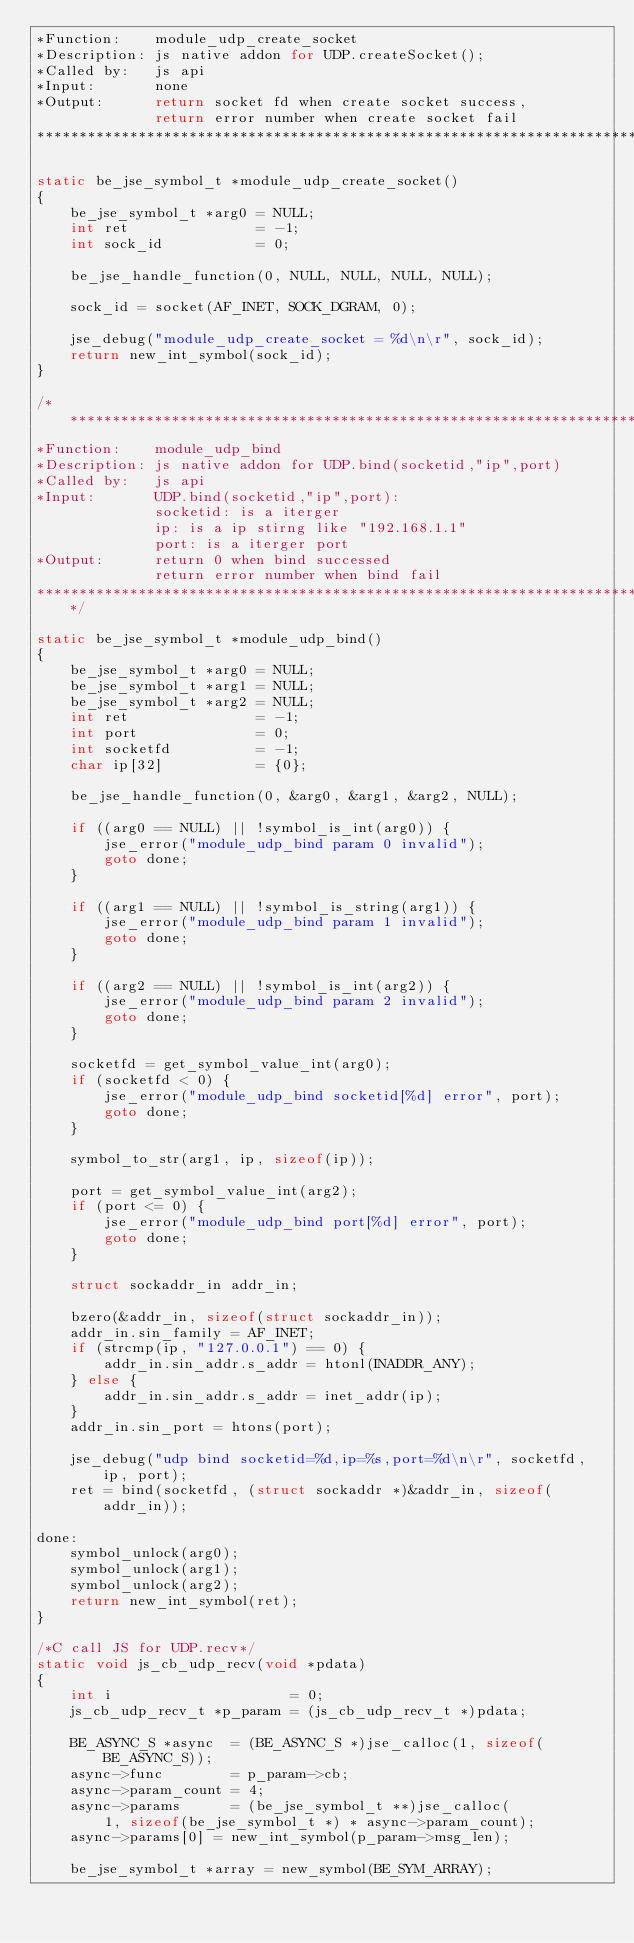Convert code to text. <code><loc_0><loc_0><loc_500><loc_500><_C_>*Function:    module_udp_create_socket
*Description: js native addon for UDP.createSocket();
*Called by:   js api
*Input:       none
*Output:      return socket fd when create socket success,
              return error number when create socket fail
**************************************************************************************/

static be_jse_symbol_t *module_udp_create_socket()
{
    be_jse_symbol_t *arg0 = NULL;
    int ret               = -1;
    int sock_id           = 0;

    be_jse_handle_function(0, NULL, NULL, NULL, NULL);

    sock_id = socket(AF_INET, SOCK_DGRAM, 0);

    jse_debug("module_udp_create_socket = %d\n\r", sock_id);
    return new_int_symbol(sock_id);
}

/*************************************************************************************
*Function:    module_udp_bind
*Description: js native addon for UDP.bind(socketid,"ip",port)
*Called by:   js api
*Input:       UDP.bind(socketid,"ip",port):
              socketid: is a iterger
              ip: is a ip stirng like "192.168.1.1"
              port: is a iterger port
*Output:      return 0 when bind successed
              return error number when bind fail
**************************************************************************************/

static be_jse_symbol_t *module_udp_bind()
{
    be_jse_symbol_t *arg0 = NULL;
    be_jse_symbol_t *arg1 = NULL;
    be_jse_symbol_t *arg2 = NULL;
    int ret               = -1;
    int port              = 0;
    int socketfd          = -1;
    char ip[32]           = {0};

    be_jse_handle_function(0, &arg0, &arg1, &arg2, NULL);

    if ((arg0 == NULL) || !symbol_is_int(arg0)) {
        jse_error("module_udp_bind param 0 invalid");
        goto done;
    }

    if ((arg1 == NULL) || !symbol_is_string(arg1)) {
        jse_error("module_udp_bind param 1 invalid");
        goto done;
    }

    if ((arg2 == NULL) || !symbol_is_int(arg2)) {
        jse_error("module_udp_bind param 2 invalid");
        goto done;
    }

    socketfd = get_symbol_value_int(arg0);
    if (socketfd < 0) {
        jse_error("module_udp_bind socketid[%d] error", port);
        goto done;
    }

    symbol_to_str(arg1, ip, sizeof(ip));

    port = get_symbol_value_int(arg2);
    if (port <= 0) {
        jse_error("module_udp_bind port[%d] error", port);
        goto done;
    }

    struct sockaddr_in addr_in;

    bzero(&addr_in, sizeof(struct sockaddr_in));
    addr_in.sin_family = AF_INET;
    if (strcmp(ip, "127.0.0.1") == 0) {
        addr_in.sin_addr.s_addr = htonl(INADDR_ANY);
    } else {
        addr_in.sin_addr.s_addr = inet_addr(ip);
    }
    addr_in.sin_port = htons(port);

    jse_debug("udp bind socketid=%d,ip=%s,port=%d\n\r", socketfd, ip, port);
    ret = bind(socketfd, (struct sockaddr *)&addr_in, sizeof(addr_in));

done:
    symbol_unlock(arg0);
    symbol_unlock(arg1);
    symbol_unlock(arg2);
    return new_int_symbol(ret);
}

/*C call JS for UDP.recv*/
static void js_cb_udp_recv(void *pdata)
{
    int i                     = 0;
    js_cb_udp_recv_t *p_param = (js_cb_udp_recv_t *)pdata;

    BE_ASYNC_S *async  = (BE_ASYNC_S *)jse_calloc(1, sizeof(BE_ASYNC_S));
    async->func        = p_param->cb;
    async->param_count = 4;
    async->params      = (be_jse_symbol_t **)jse_calloc(
        1, sizeof(be_jse_symbol_t *) * async->param_count);
    async->params[0] = new_int_symbol(p_param->msg_len);

    be_jse_symbol_t *array = new_symbol(BE_SYM_ARRAY);</code> 